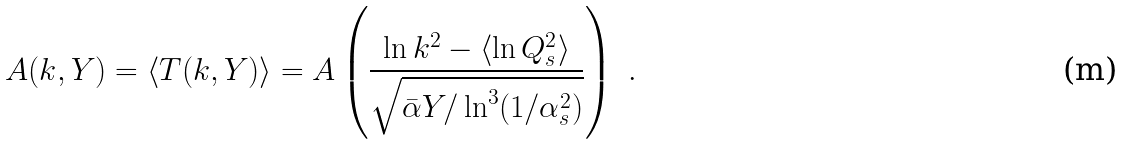<formula> <loc_0><loc_0><loc_500><loc_500>A ( k , Y ) = \langle T ( k , Y ) \rangle = A \left ( \frac { \ln k ^ { 2 } - \langle \ln Q _ { s } ^ { 2 } \rangle } { \sqrt { \bar { \alpha } Y / \ln ^ { 3 } ( 1 / \alpha _ { s } ^ { 2 } ) } } \right ) \ .</formula> 